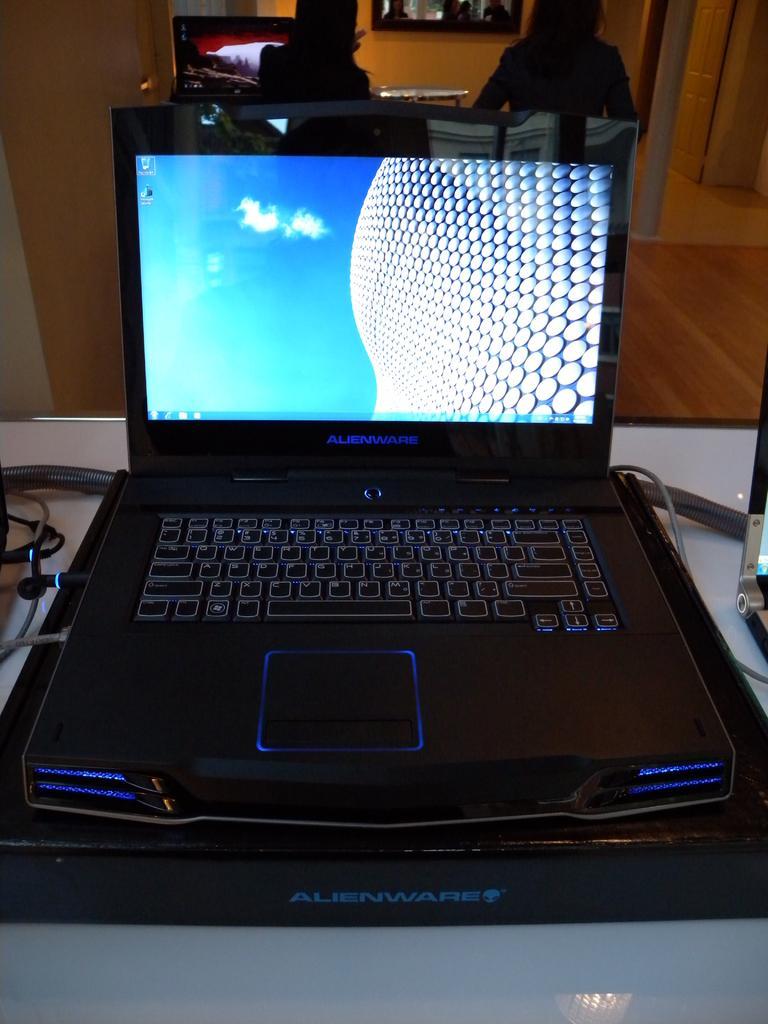<image>
Present a compact description of the photo's key features. A laptop with the Alienware logo lit up in blue on it. 